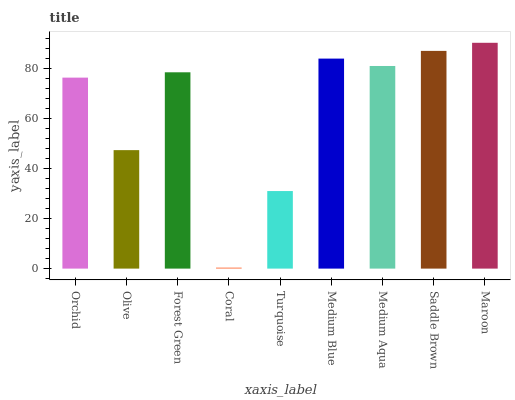Is Coral the minimum?
Answer yes or no. Yes. Is Maroon the maximum?
Answer yes or no. Yes. Is Olive the minimum?
Answer yes or no. No. Is Olive the maximum?
Answer yes or no. No. Is Orchid greater than Olive?
Answer yes or no. Yes. Is Olive less than Orchid?
Answer yes or no. Yes. Is Olive greater than Orchid?
Answer yes or no. No. Is Orchid less than Olive?
Answer yes or no. No. Is Forest Green the high median?
Answer yes or no. Yes. Is Forest Green the low median?
Answer yes or no. Yes. Is Olive the high median?
Answer yes or no. No. Is Medium Aqua the low median?
Answer yes or no. No. 